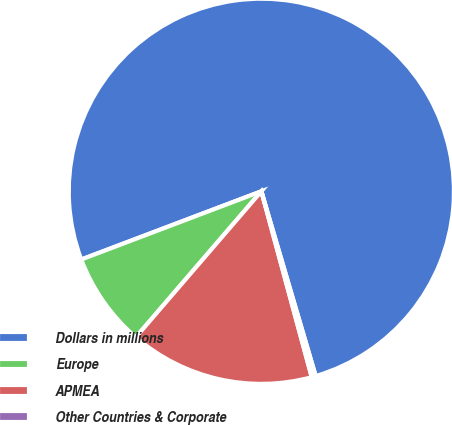Convert chart. <chart><loc_0><loc_0><loc_500><loc_500><pie_chart><fcel>Dollars in millions<fcel>Europe<fcel>APMEA<fcel>Other Countries & Corporate<nl><fcel>76.21%<fcel>7.93%<fcel>15.52%<fcel>0.34%<nl></chart> 